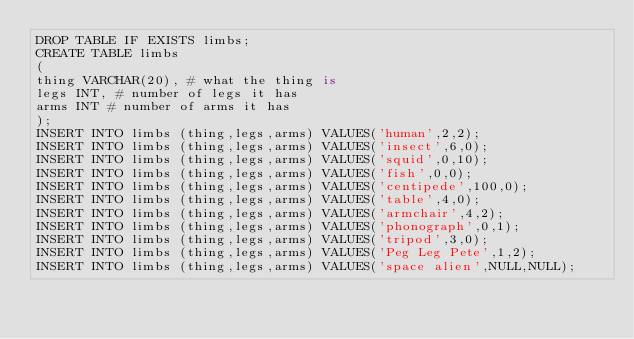Convert code to text. <code><loc_0><loc_0><loc_500><loc_500><_SQL_>DROP TABLE IF EXISTS limbs; 
CREATE TABLE limbs
(
thing VARCHAR(20), # what the thing is 
legs INT, # number of legs it has 
arms INT # number of arms it has
);
INSERT INTO limbs (thing,legs,arms) VALUES('human',2,2);
INSERT INTO limbs (thing,legs,arms) VALUES('insect',6,0);
INSERT INTO limbs (thing,legs,arms) VALUES('squid',0,10);
INSERT INTO limbs (thing,legs,arms) VALUES('fish',0,0);
INSERT INTO limbs (thing,legs,arms) VALUES('centipede',100,0); 
INSERT INTO limbs (thing,legs,arms) VALUES('table',4,0);
INSERT INTO limbs (thing,legs,arms) VALUES('armchair',4,2);
INSERT INTO limbs (thing,legs,arms) VALUES('phonograph',0,1); 
INSERT INTO limbs (thing,legs,arms) VALUES('tripod',3,0);
INSERT INTO limbs (thing,legs,arms) VALUES('Peg Leg Pete',1,2); 
INSERT INTO limbs (thing,legs,arms) VALUES('space alien',NULL,NULL);</code> 